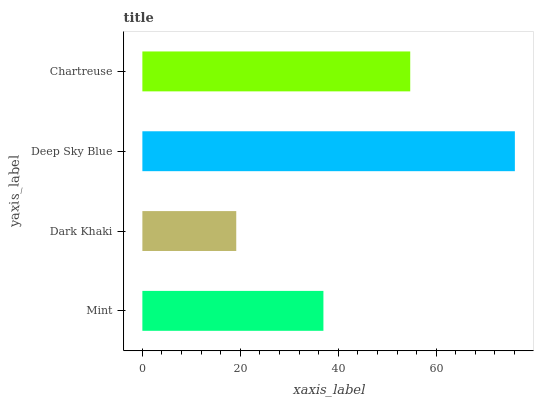Is Dark Khaki the minimum?
Answer yes or no. Yes. Is Deep Sky Blue the maximum?
Answer yes or no. Yes. Is Deep Sky Blue the minimum?
Answer yes or no. No. Is Dark Khaki the maximum?
Answer yes or no. No. Is Deep Sky Blue greater than Dark Khaki?
Answer yes or no. Yes. Is Dark Khaki less than Deep Sky Blue?
Answer yes or no. Yes. Is Dark Khaki greater than Deep Sky Blue?
Answer yes or no. No. Is Deep Sky Blue less than Dark Khaki?
Answer yes or no. No. Is Chartreuse the high median?
Answer yes or no. Yes. Is Mint the low median?
Answer yes or no. Yes. Is Deep Sky Blue the high median?
Answer yes or no. No. Is Chartreuse the low median?
Answer yes or no. No. 